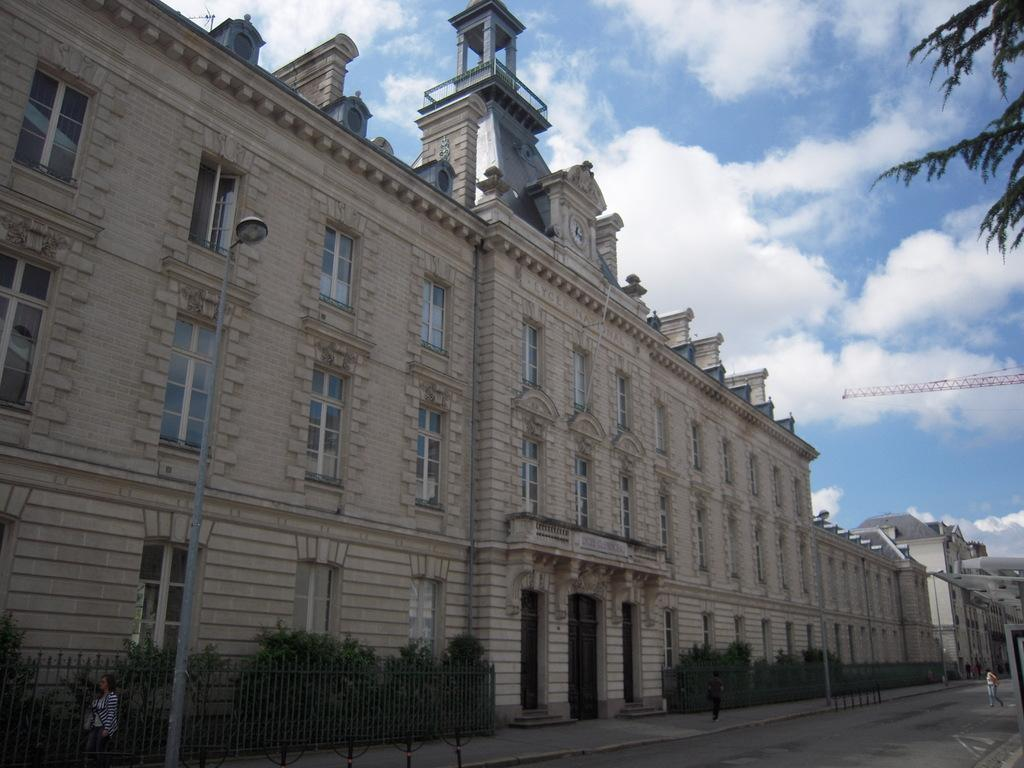What can be seen on the left side of the image? There are buildings, windows, plants, street lights, pillars, and a wall on the left side of the image. What is the composition of the left side of the image? The left side of the image consists of architectural elements such as buildings, windows, and pillars, as well as natural elements like plants and a wall. What is visible on the right side of the image? There are trees, a person, a road, and sky visible on the right side of the image. What is the weather like in the image? The sky is visible with clouds, indicating that it is a partly cloudy day. What type of drink is being offered by the person on the right side of the image? There is no person offering a drink in the image; the person is simply standing on the right side of the image. What type of wood can be seen in the image? There is no wood present in the image. 